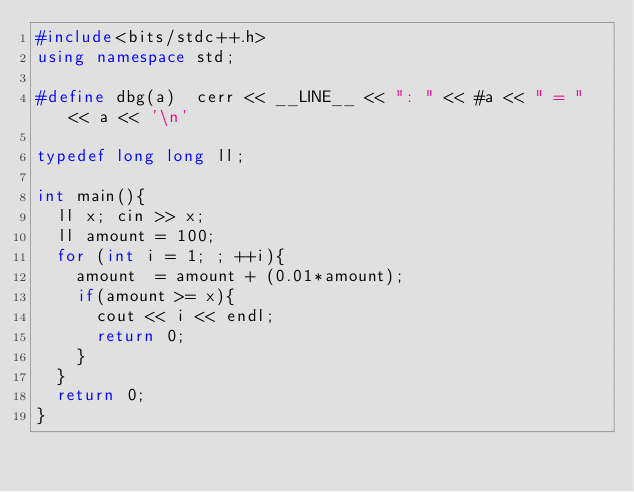Convert code to text. <code><loc_0><loc_0><loc_500><loc_500><_C++_>#include<bits/stdc++.h>
using namespace std;

#define dbg(a)  cerr << __LINE__ << ": " << #a << " = " << a << '\n'

typedef long long ll;

int main(){
  ll x; cin >> x;
  ll amount = 100;
  for (int i = 1; ; ++i){
    amount  = amount + (0.01*amount);
    if(amount >= x){
      cout << i << endl;
      return 0;
    }
  }
  return 0;
}</code> 